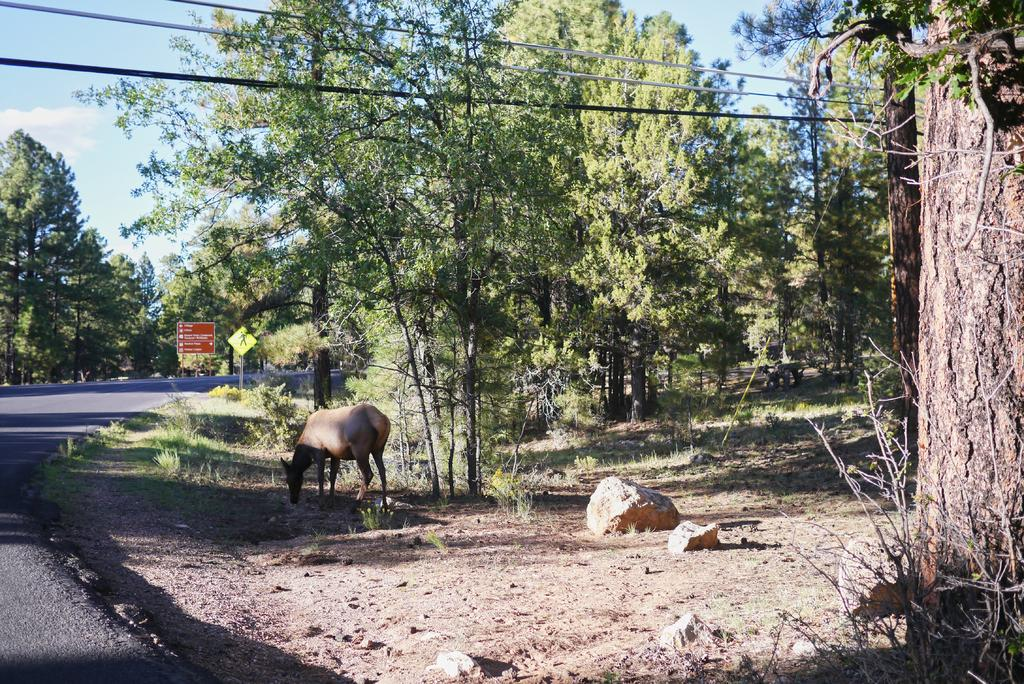What type of animal can be seen in the image? There is an animal in the image, but we cannot determine its specific type from the provided facts. What natural elements are present in the image? There are rocks, grass, trees, and a road on the left side of the image. What man-made structures can be seen in the image? There are wires, boards, and a road on the left side of the image. What is visible in the background of the image? The sky is visible in the background of the image. What type of dinner is being served on a scale in the image? There is no dinner or scale present in the image. What flavor of pie can be seen in the image? There is no pie present in the image. 